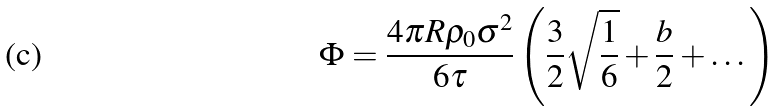<formula> <loc_0><loc_0><loc_500><loc_500>\Phi = \frac { 4 \pi R \rho _ { 0 } \sigma ^ { 2 } } { 6 \tau } \left ( \frac { 3 } { 2 } \sqrt { \frac { 1 } { 6 } } + \frac { b } { 2 } + \dots \right )</formula> 